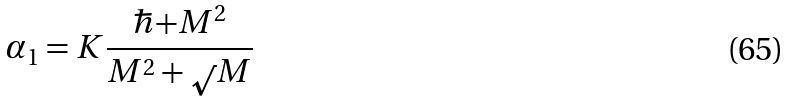<formula> <loc_0><loc_0><loc_500><loc_500>\alpha _ { 1 } = K \frac { \hbar { + } M ^ { 2 } } { M ^ { 2 } + \sqrt { } M }</formula> 